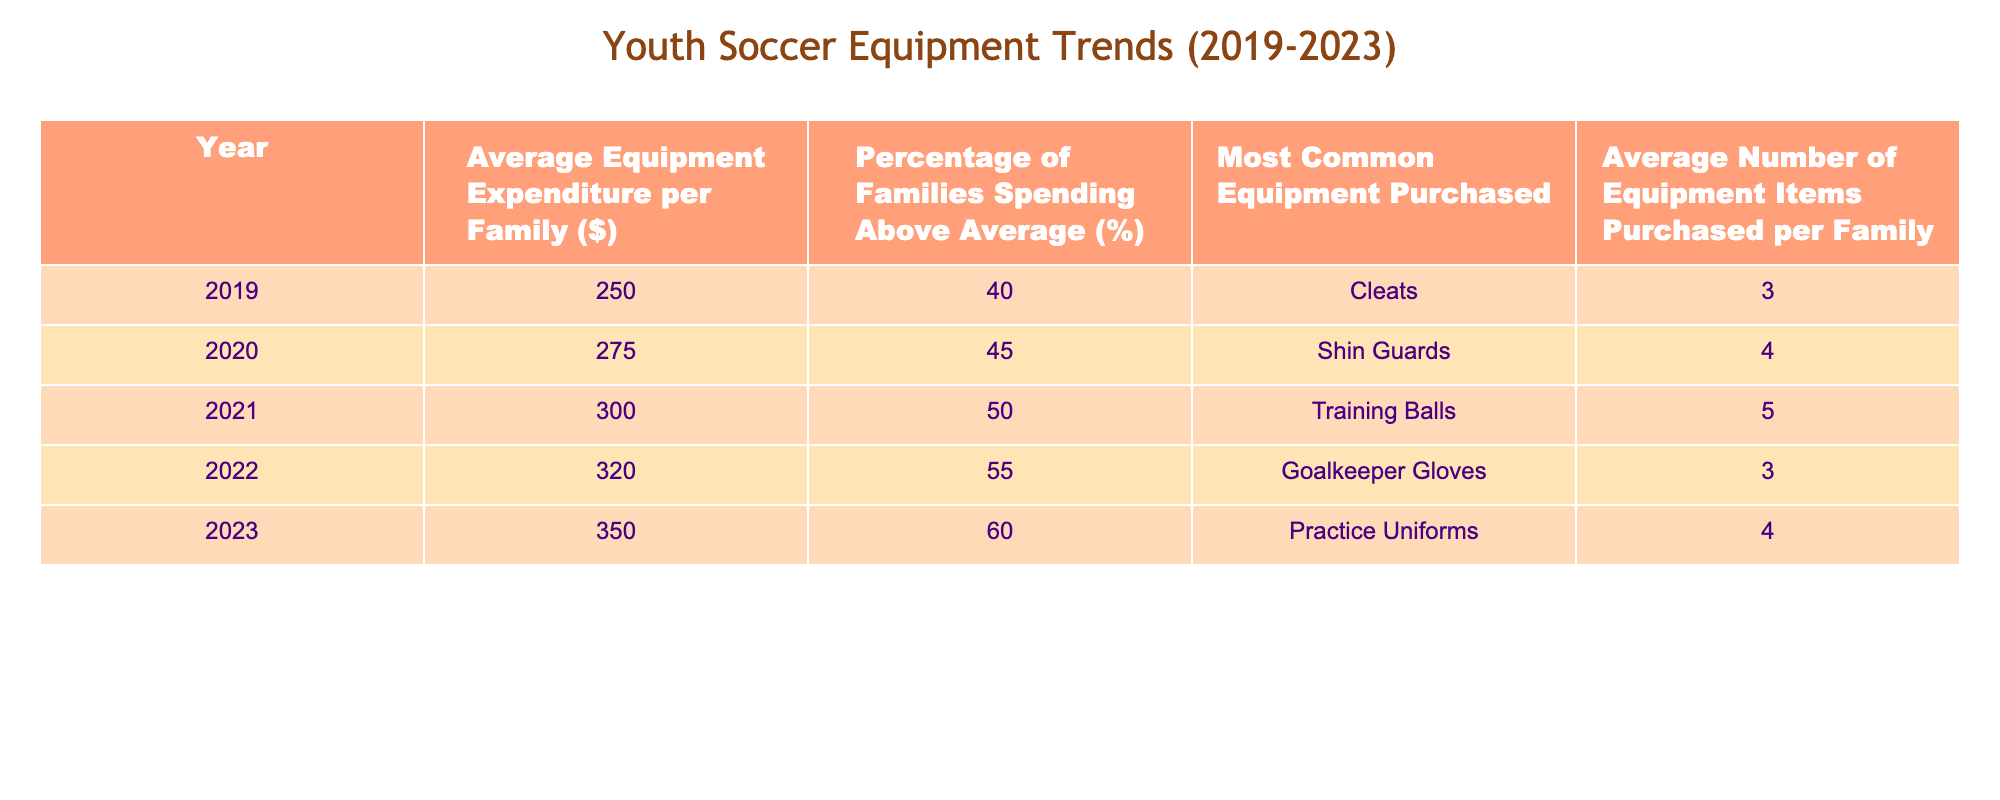What was the average equipment expenditure in 2021? In the table, the row for the year 2021 shows the average equipment expenditure per family as 300 dollars.
Answer: 300 Which year had the highest percentage of families spending above average? The highest percentage of families spending above average is recorded in 2023, with 60%.
Answer: 2023 What is the most common equipment purchased in 2020? The table indicates that the most common equipment purchased in 2020 was shin guards.
Answer: Shin Guards What was the average equipment expenditure increase from 2019 to 2023? The average expenditure in 2019 was 250 dollars, and in 2023 it was 350 dollars. The increase is 350 - 250 = 100 dollars.
Answer: 100 Is it true that more than half of families spent above average in 2022? In 2022, the percentage of families spending above average was 55%, which is indeed more than half.
Answer: Yes What was the average number of equipment items purchased in 2020 and 2021 combined? In 2020, the average number of items was 4, and in 2021 it was 5. Their combined total is 4 + 5 = 9, so the average is 9/2 = 4.5.
Answer: 4.5 What was the trend in the average equipment expenditure from 2019 to 2023? The table shows a consistent increase in average equipment expenditure from 250 dollars in 2019 to 350 dollars in 2023, indicating a positive trend.
Answer: Increasing What equipment had the same average number of items purchased in 2019 and 2022? Both rows for 2019 and 2022 show that 3 items were purchased on average, specifically cleats in 2019 and goalkeeper gloves in 2022.
Answer: Cleats and Goalkeeper Gloves Is it correct that the average expenditure in 2022 was higher than in 2020? Comparing the values, the average expenditure in 2022 was 320 dollars, while in 2020 it was 275 dollars; therefore, it is true that 2022's expenditure was higher.
Answer: Yes 